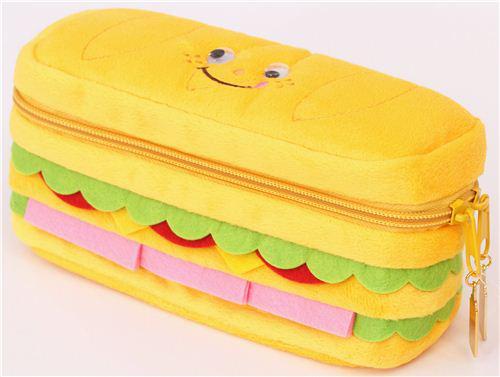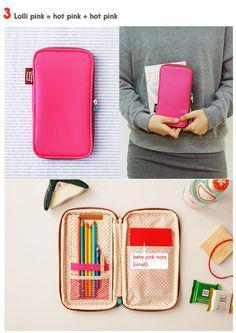The first image is the image on the left, the second image is the image on the right. Considering the images on both sides, is "The right image contains four different colored small bags." valid? Answer yes or no. No. The first image is the image on the left, the second image is the image on the right. For the images displayed, is the sentence "There are four cases in the image on the left." factually correct? Answer yes or no. No. 